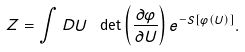Convert formula to latex. <formula><loc_0><loc_0><loc_500><loc_500>Z = \int D U \ \det \left ( \frac { \partial \varphi } { \partial U } \right ) e ^ { - S [ \varphi ( U ) ] } .</formula> 